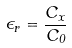<formula> <loc_0><loc_0><loc_500><loc_500>\epsilon _ { r } = \frac { C _ { x } } { C _ { 0 } }</formula> 